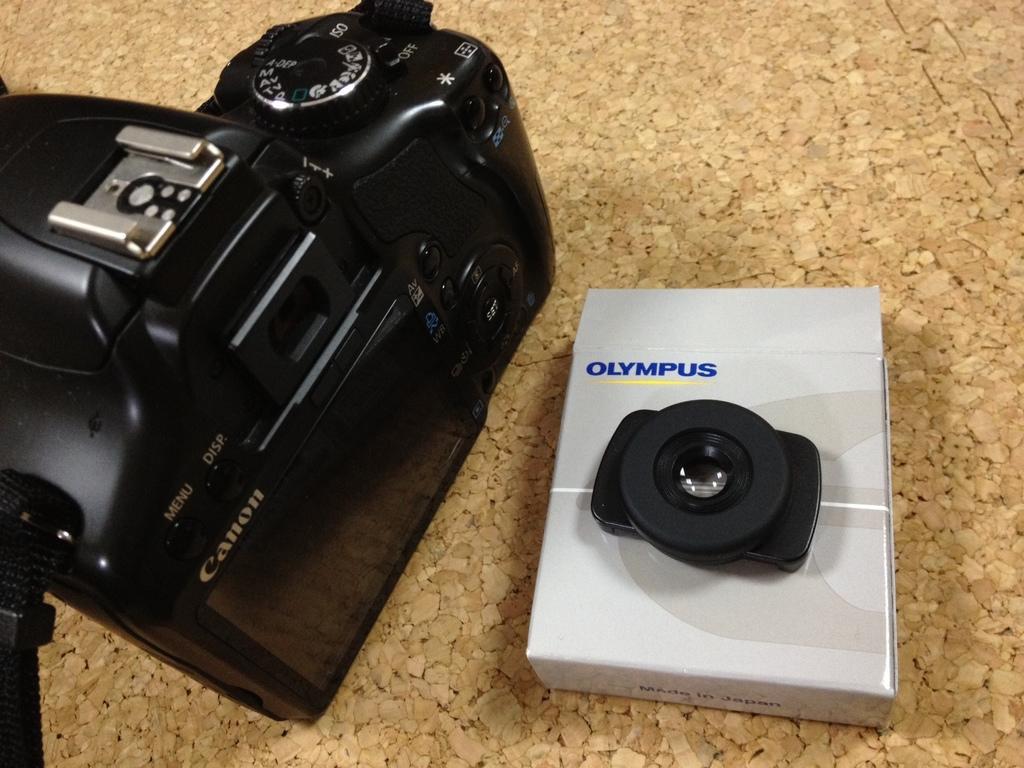How would you summarize this image in a sentence or two? In this image I can see a black colour camera, a white colour box and on it I can see a black colour. I can also see something is written at many places. 